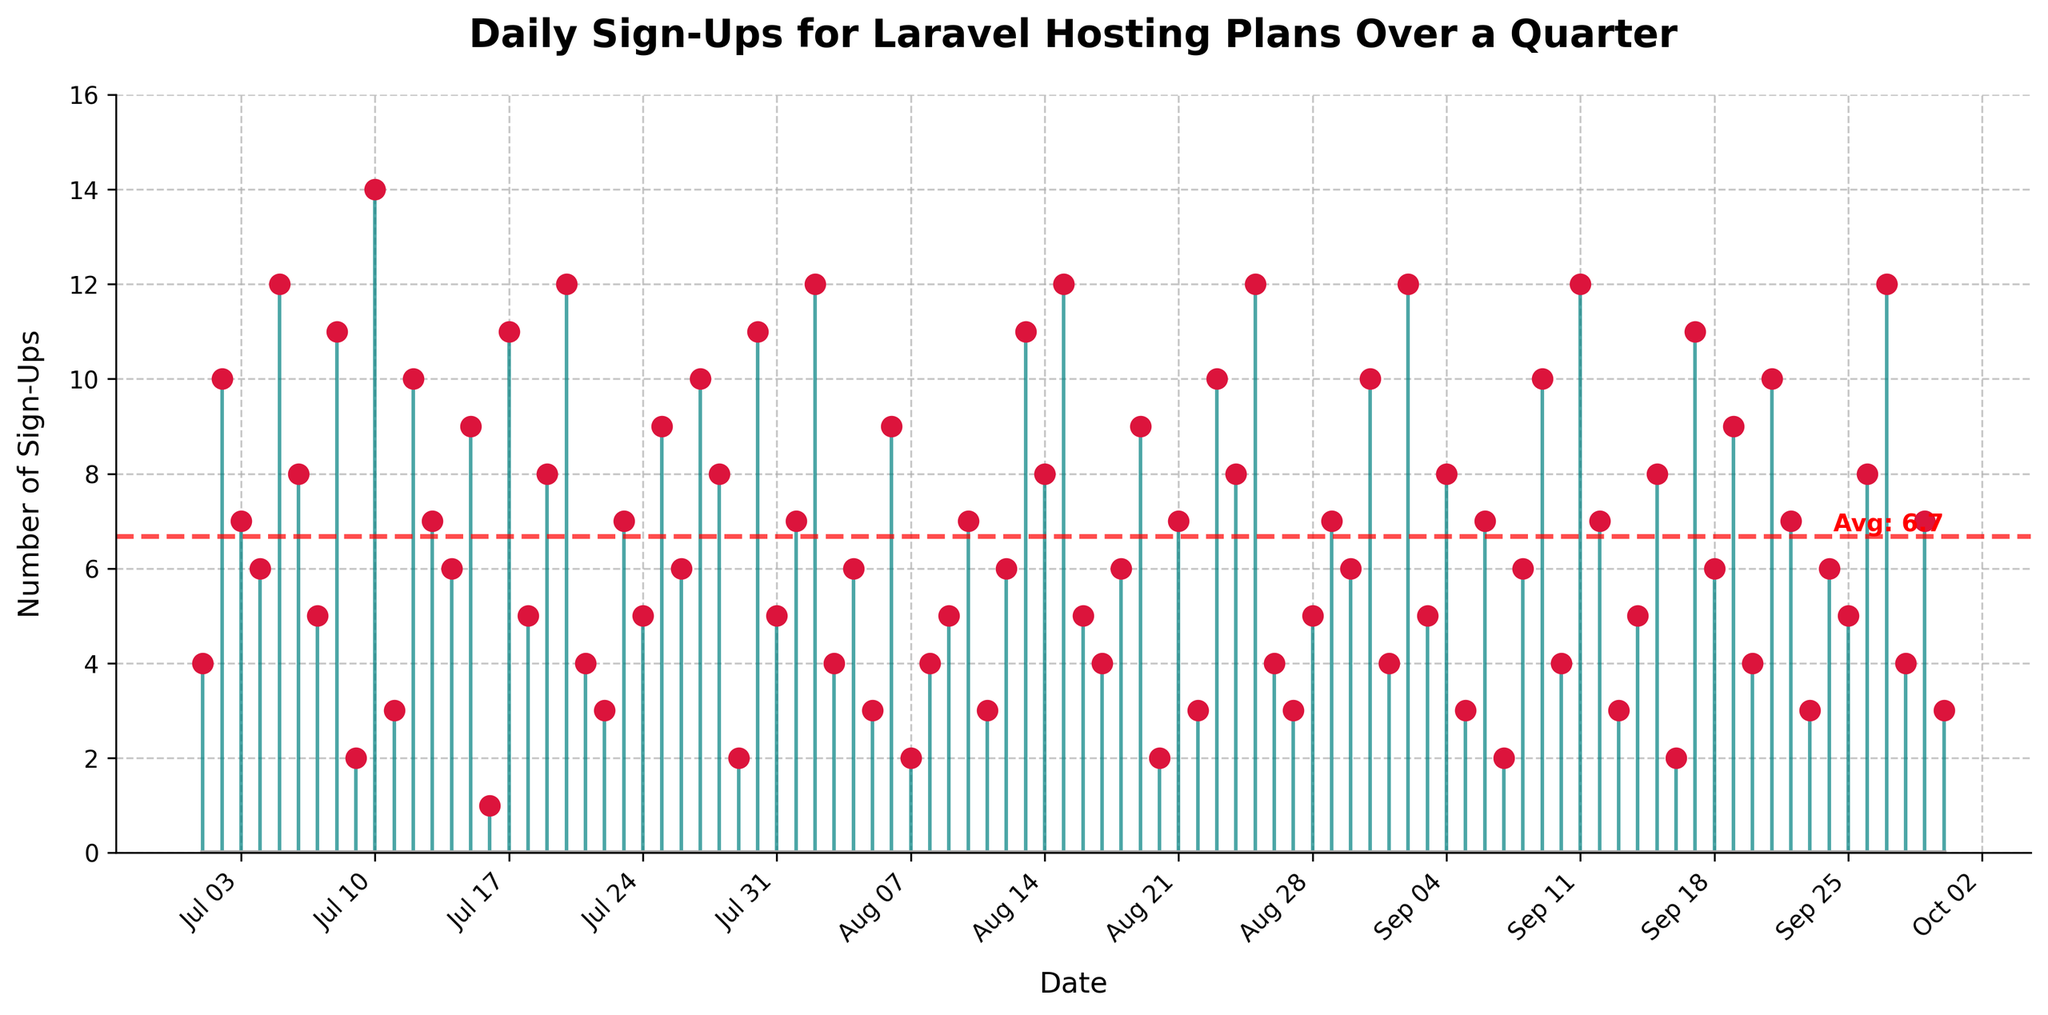What's the title of the figure? The title is positioned at the top of the figure and reads "Daily Sign-Ups for Laravel Hosting Plans Over a Quarter."
Answer: Daily Sign-Ups for Laravel Hosting Plans Over a Quarter What is the marker color used for the data points on the stem plot? The color of the markers can be seen as bright red dots on each stem.
Answer: crimson How many sign-ups were there on the day with the highest number of sign-ups? The highest peak on the y-axis indicates 14 sign-ups on 2023-07-10.
Answer: 14 What is the average number of daily sign-ups? The average line is marked on the figure as a dashed red line with a value labeled next to it.
Answer: 6.5667 On which date did the least number of sign-ups occur and how many were there? The lowest point on the y-axis indicates 1 sign-up, and the corresponding date is 2023-07-16.
Answer: 2023-07-16, 1 Compare the number of sign-ups on July 15, 2023, and August 15, 2023. Which date had more sign-ups? By locating the stems for these dates, we see there were 9 sign-ups on July 15 and 12 sign-ups on August 15.
Answer: August 15, 2023 What trend do you notice in the sign-up patterns over the entire quarter? By visually inspecting the stems and their heights, we notice sign-ups fluctuate with no consistent upward or downward trend, indicating variability.
Answer: Fluctuating, no consistent trend How often did the number of daily sign-ups reach or exceed 10 in the quarter? Locate each instance where the stem reaches or exceeds the value of 10 on the y-axis, counting them up—seven occurrences can be identified: 2023-07-05, 2023-07-10, 2023-07-27, 2023-08-13, 2023-08-23, 2023-09-09, and 2023-09-17.
Answer: 7 times 